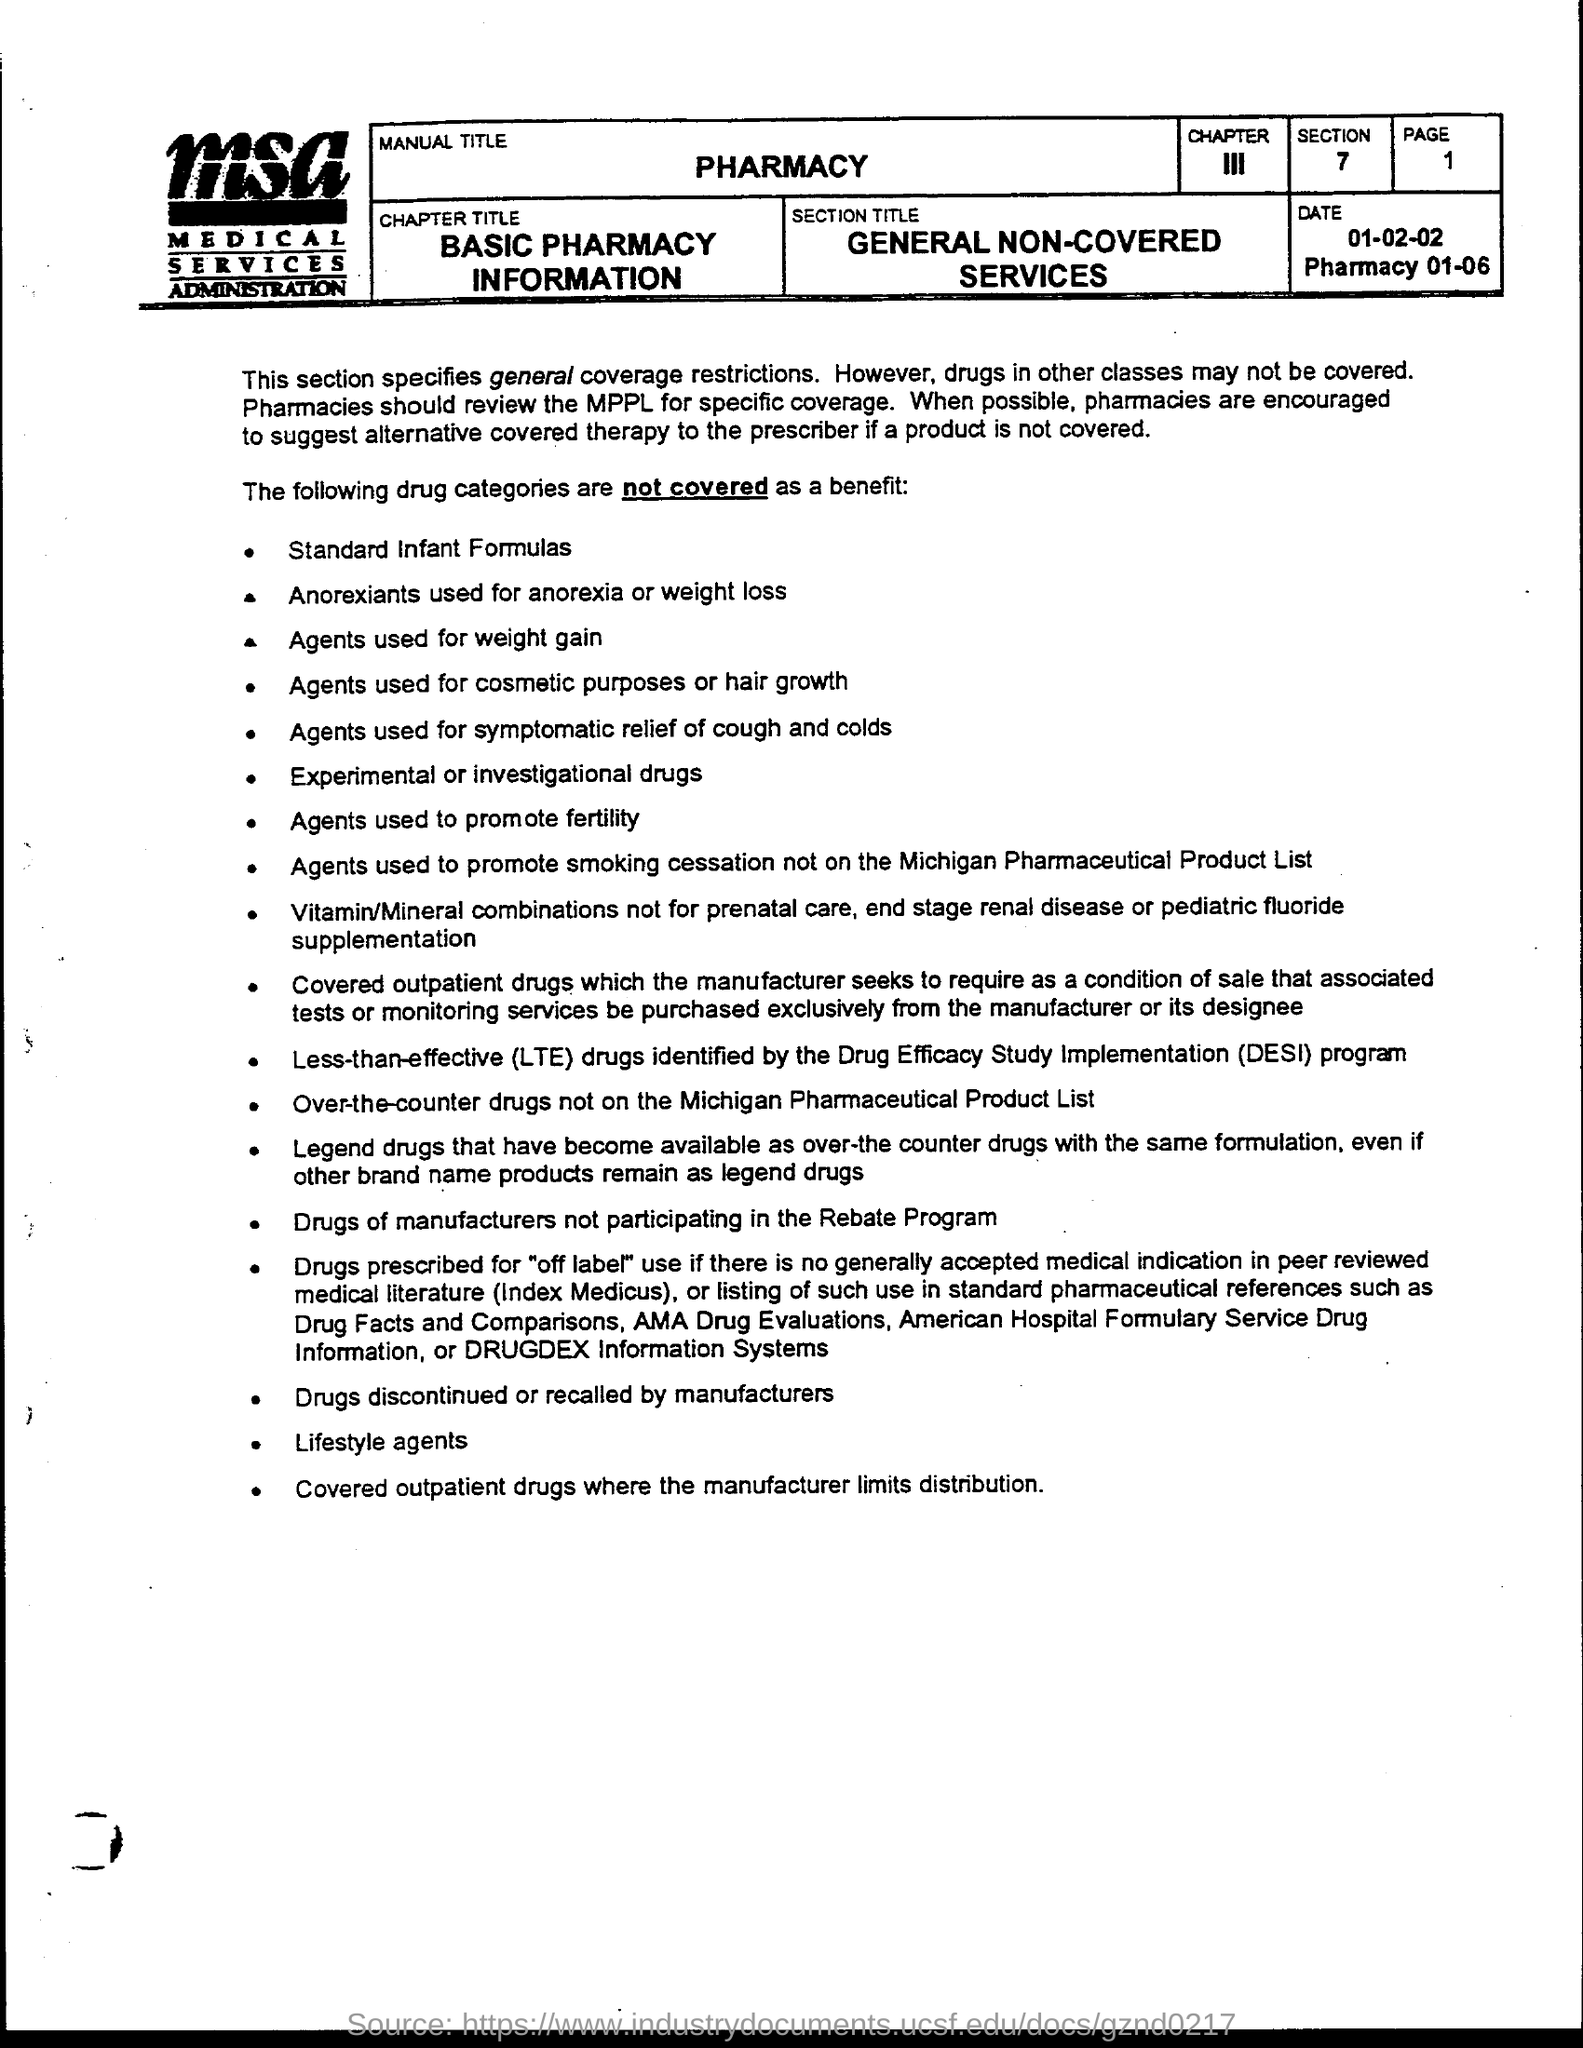Identify some key points in this picture. MSA stands for Medical Services Administration, a field of study and industry that focuses on the efficient management and administration of medical services, including hospitals, clinics, and other healthcare facilities. What is the Chapter Title? Basic Pharmacy Information... The page number is 1, and it ranges from 1 to... The section is 7.. On what date is it? 